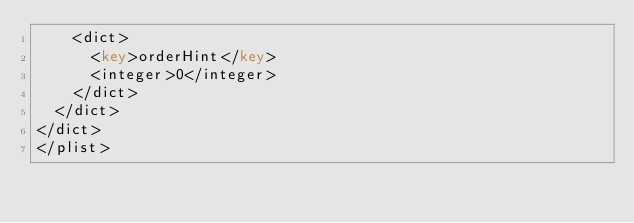<code> <loc_0><loc_0><loc_500><loc_500><_XML_>		<dict>
			<key>orderHint</key>
			<integer>0</integer>
		</dict>
	</dict>
</dict>
</plist>
</code> 